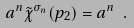Convert formula to latex. <formula><loc_0><loc_0><loc_500><loc_500>a ^ { n } \tilde { \chi } ^ { \sigma _ { n } } ( p _ { 2 } ) = a ^ { n } \ .</formula> 